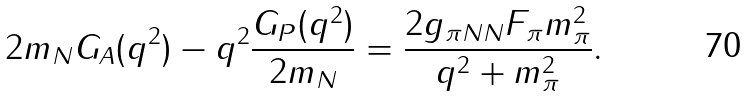<formula> <loc_0><loc_0><loc_500><loc_500>2 m _ { N } G _ { A } ( q ^ { 2 } ) - q ^ { 2 } \frac { G _ { P } ( q ^ { 2 } ) } { 2 m _ { N } } = \frac { 2 g _ { \pi N N } F _ { \pi } m _ { \pi } ^ { 2 } } { q ^ { 2 } + m _ { \pi } ^ { 2 } } .</formula> 